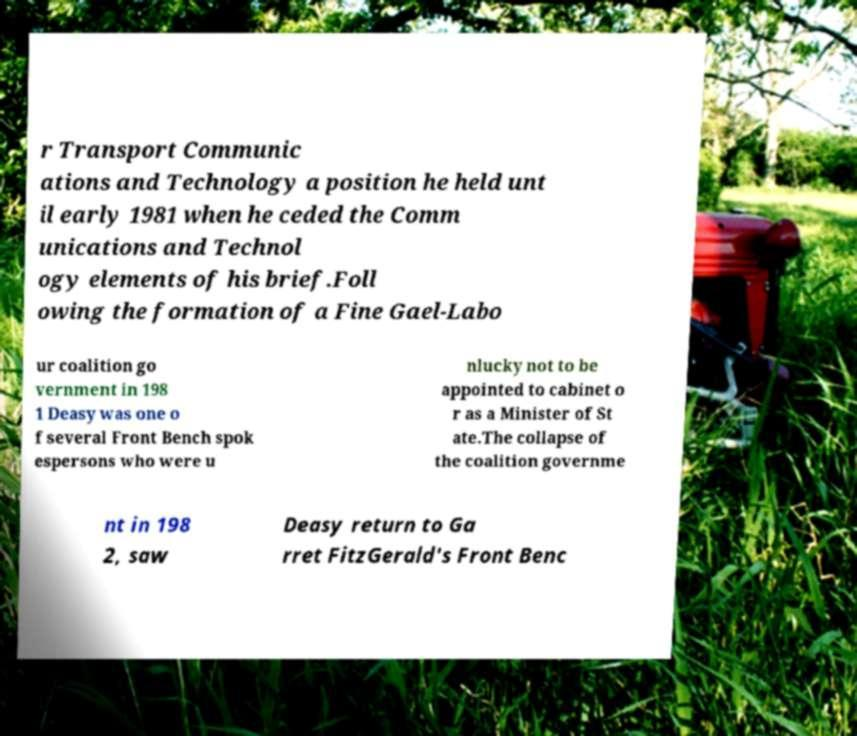Can you read and provide the text displayed in the image?This photo seems to have some interesting text. Can you extract and type it out for me? r Transport Communic ations and Technology a position he held unt il early 1981 when he ceded the Comm unications and Technol ogy elements of his brief.Foll owing the formation of a Fine Gael-Labo ur coalition go vernment in 198 1 Deasy was one o f several Front Bench spok espersons who were u nlucky not to be appointed to cabinet o r as a Minister of St ate.The collapse of the coalition governme nt in 198 2, saw Deasy return to Ga rret FitzGerald's Front Benc 